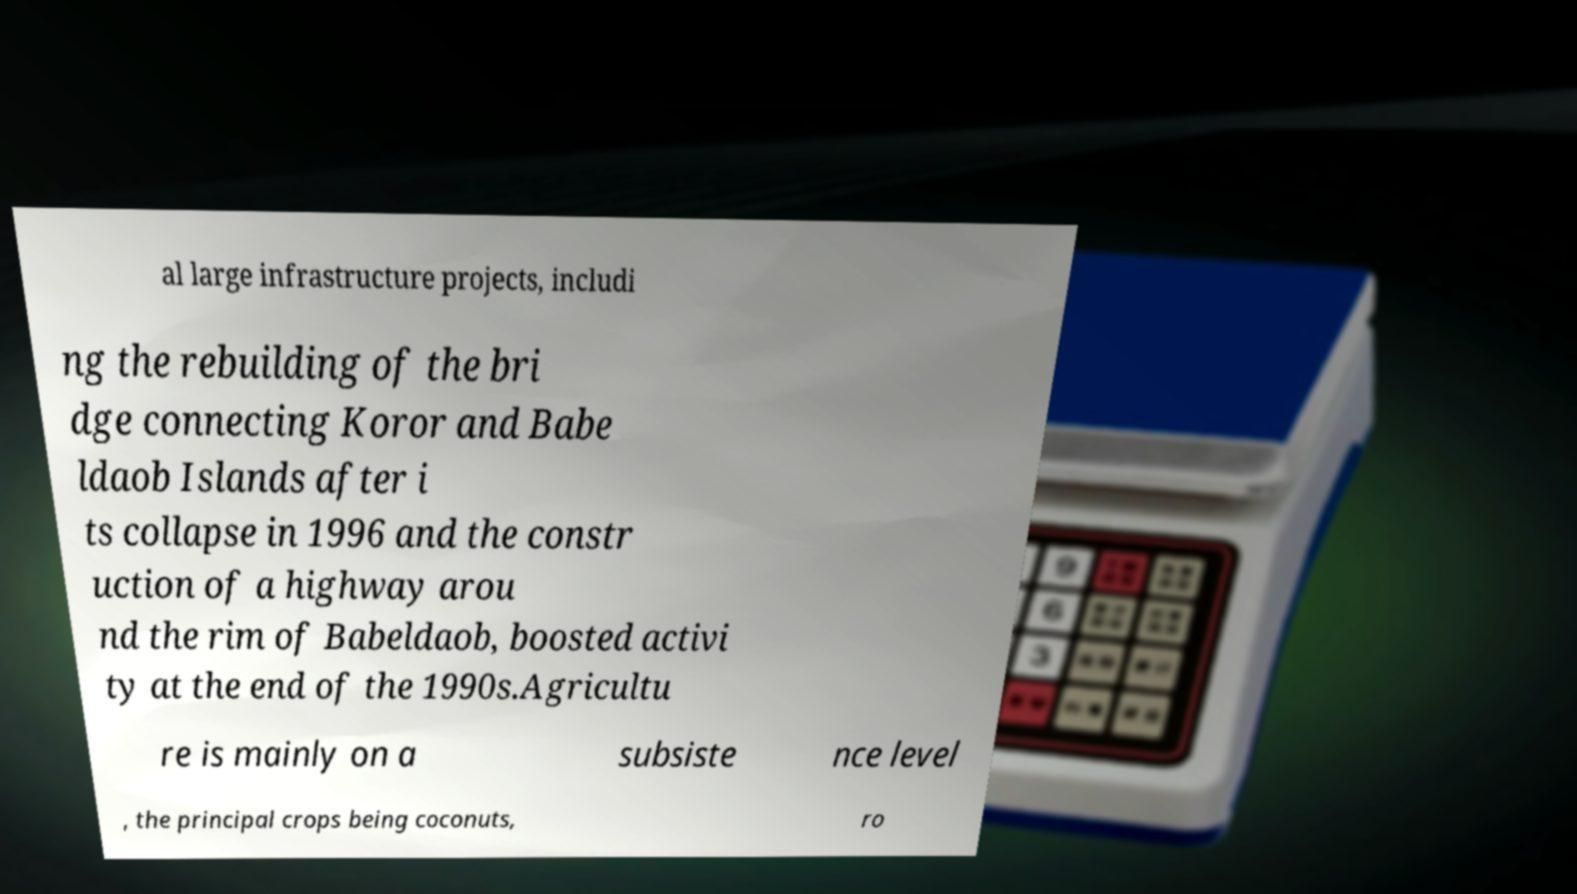For documentation purposes, I need the text within this image transcribed. Could you provide that? al large infrastructure projects, includi ng the rebuilding of the bri dge connecting Koror and Babe ldaob Islands after i ts collapse in 1996 and the constr uction of a highway arou nd the rim of Babeldaob, boosted activi ty at the end of the 1990s.Agricultu re is mainly on a subsiste nce level , the principal crops being coconuts, ro 